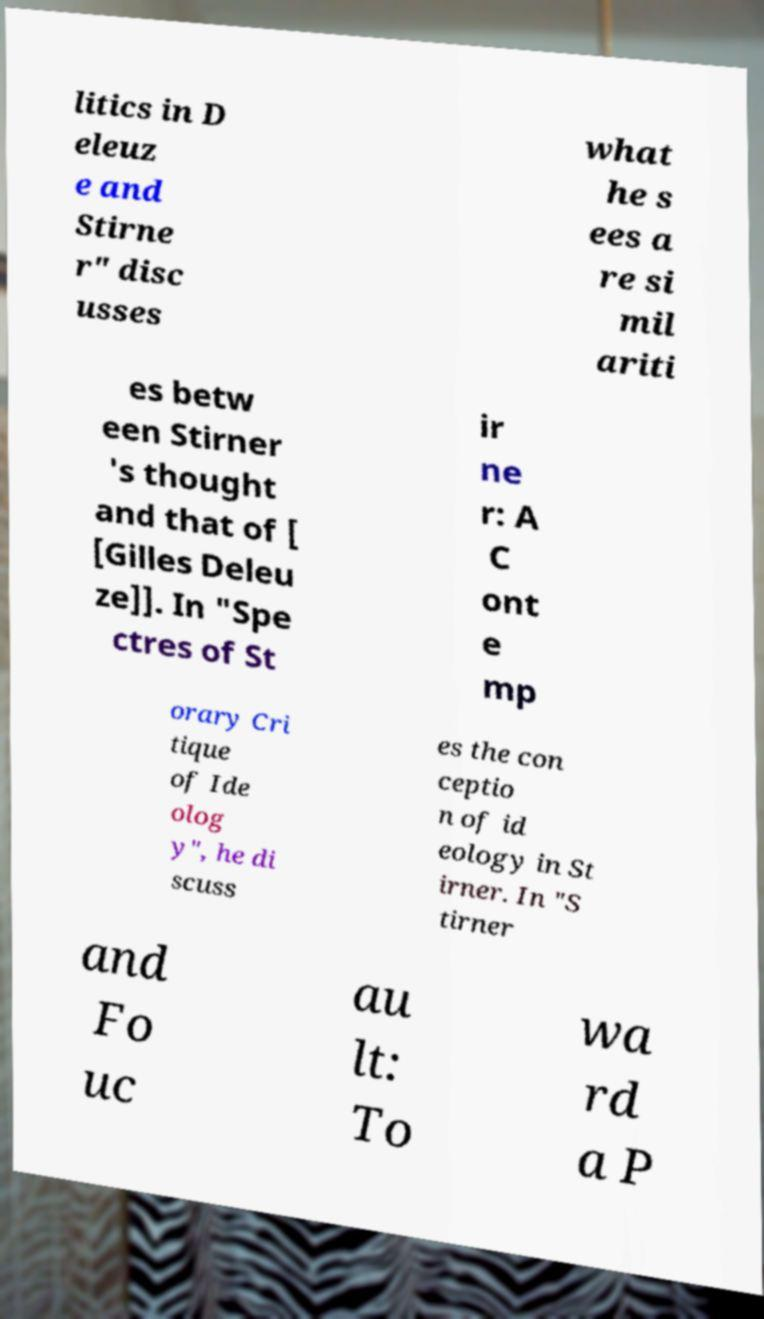Please identify and transcribe the text found in this image. litics in D eleuz e and Stirne r" disc usses what he s ees a re si mil ariti es betw een Stirner 's thought and that of [ [Gilles Deleu ze]]. In "Spe ctres of St ir ne r: A C ont e mp orary Cri tique of Ide olog y", he di scuss es the con ceptio n of id eology in St irner. In "S tirner and Fo uc au lt: To wa rd a P 